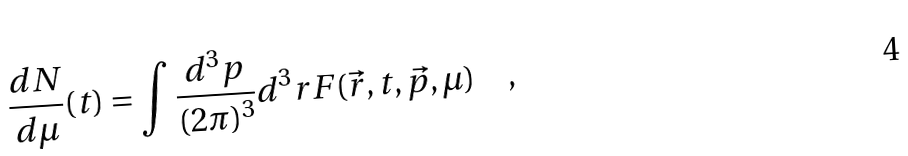<formula> <loc_0><loc_0><loc_500><loc_500>\frac { d N } { d \mu } ( t ) = \int \frac { d ^ { 3 } p } { ( 2 \pi ) ^ { 3 } } d ^ { 3 } r F ( \vec { r } , t , \vec { p } , \mu ) \quad ,</formula> 